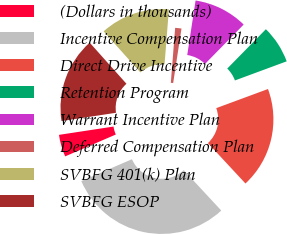<chart> <loc_0><loc_0><loc_500><loc_500><pie_chart><fcel>(Dollars in thousands)<fcel>Incentive Compensation Plan<fcel>Direct Drive Incentive<fcel>Retention Program<fcel>Warrant Incentive Plan<fcel>Deferred Compensation Plan<fcel>SVBFG 401(k) Plan<fcel>SVBFG ESOP<nl><fcel>4.08%<fcel>30.43%<fcel>18.72%<fcel>7.01%<fcel>9.94%<fcel>1.16%<fcel>12.87%<fcel>15.79%<nl></chart> 